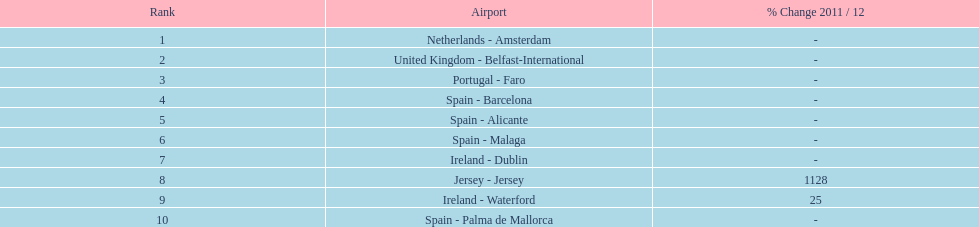Between the topped ranked airport, netherlands - amsterdam, & spain - palma de mallorca, what is the difference in the amount of passengers handled? 77,631. 